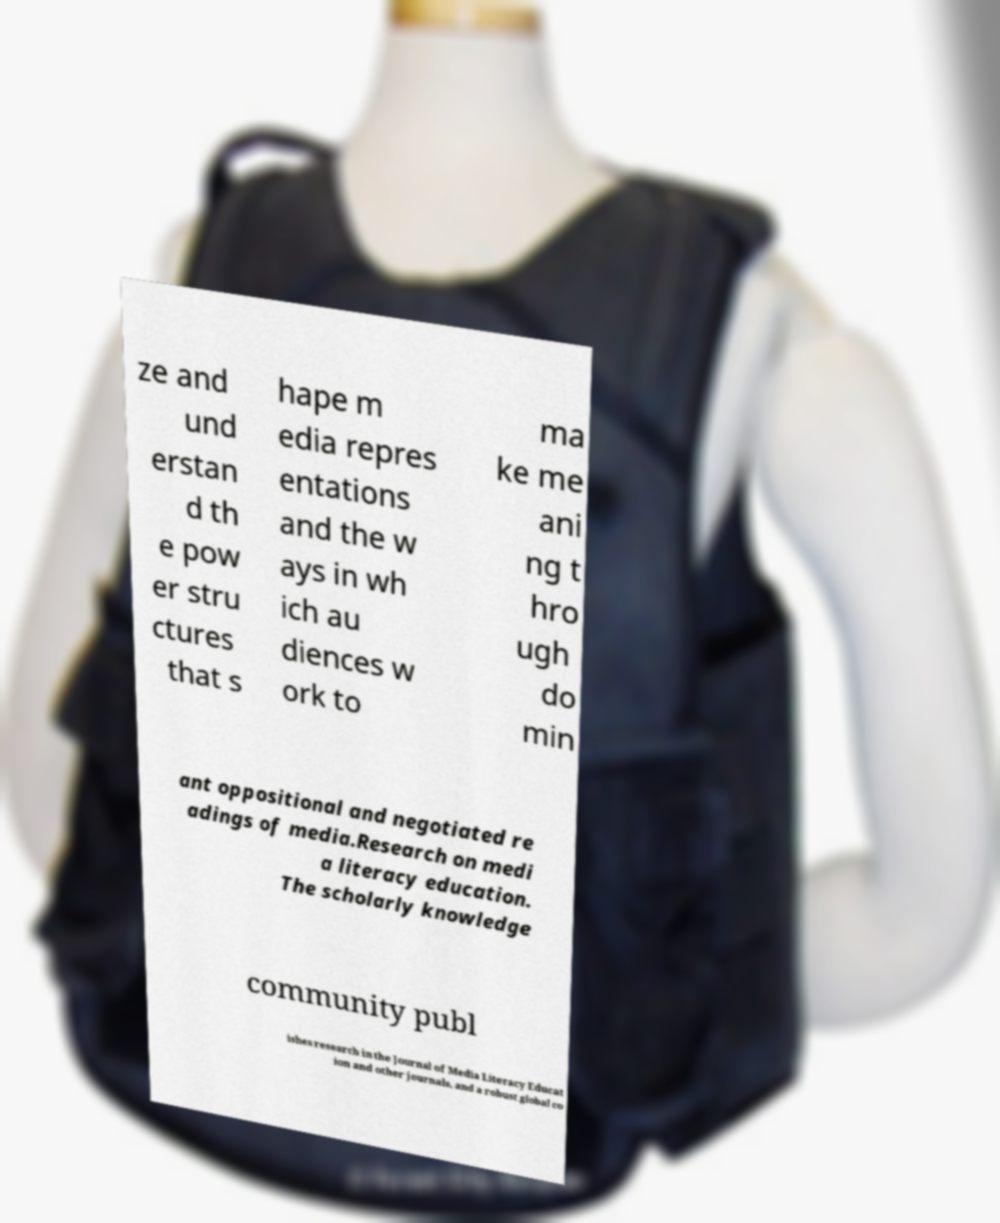Can you read and provide the text displayed in the image?This photo seems to have some interesting text. Can you extract and type it out for me? ze and und erstan d th e pow er stru ctures that s hape m edia repres entations and the w ays in wh ich au diences w ork to ma ke me ani ng t hro ugh do min ant oppositional and negotiated re adings of media.Research on medi a literacy education. The scholarly knowledge community publ ishes research in the Journal of Media Literacy Educat ion and other journals, and a robust global co 